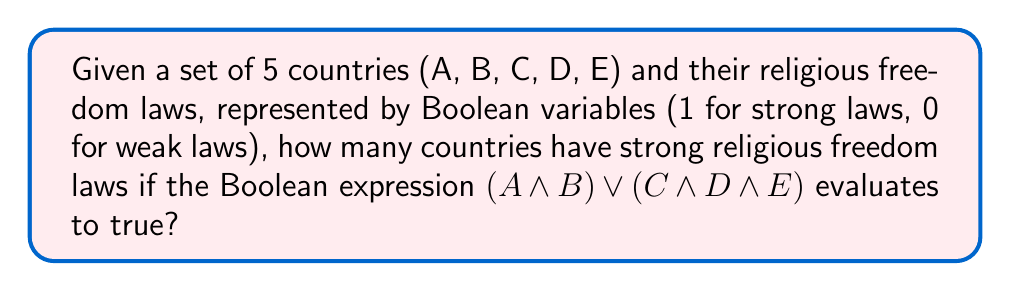Can you solve this math problem? To solve this problem, we need to analyze the Boolean expression and determine the minimum number of countries that must have strong religious freedom laws (represented by 1) for the expression to be true.

1. The expression is $(A \land B) \lor (C \land D \land E)$

2. This expression is a disjunction (OR) of two terms:
   - Term 1: $(A \land B)$
   - Term 2: $(C \land D \land E)$

3. For the entire expression to be true, at least one of these terms must be true.

4. Let's examine each term:
   - For Term 1 to be true, both A and B must be 1 (strong laws).
   - For Term 2 to be true, C, D, and E must all be 1 (strong laws).

5. The minimum number of countries with strong laws occurs when Term 1 is true and Term 2 is false:
   - A = 1, B = 1
   - C, D, E can be 0 or 1 (doesn't matter as long as at least one is 0)

6. Therefore, the minimum number of countries with strong religious freedom laws is 2 (A and B).

Note: While more countries could have strong laws, the question asks for the number of countries that must have strong laws for the expression to be true, which is 2.
Answer: 2 